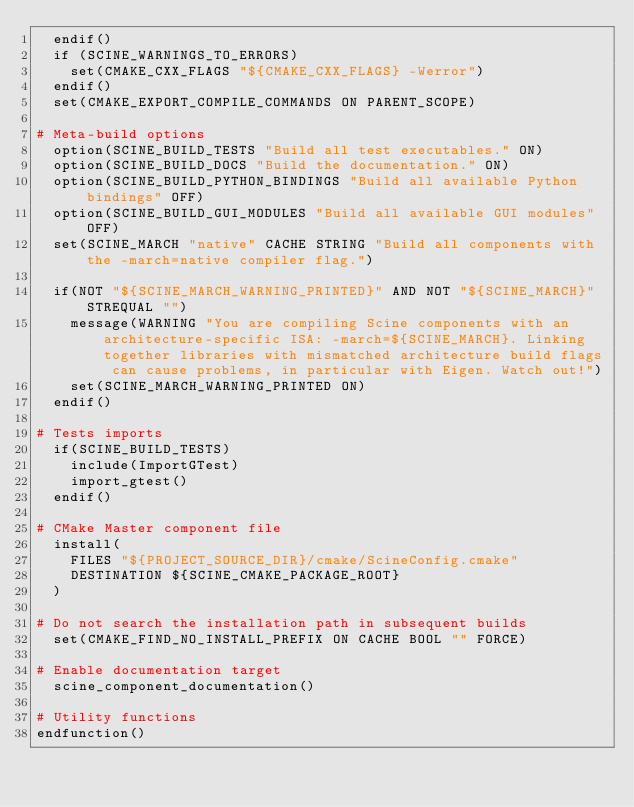Convert code to text. <code><loc_0><loc_0><loc_500><loc_500><_CMake_>  endif()
  if (SCINE_WARNINGS_TO_ERRORS)
    set(CMAKE_CXX_FLAGS "${CMAKE_CXX_FLAGS} -Werror")
  endif()
  set(CMAKE_EXPORT_COMPILE_COMMANDS ON PARENT_SCOPE)

# Meta-build options
  option(SCINE_BUILD_TESTS "Build all test executables." ON)
  option(SCINE_BUILD_DOCS "Build the documentation." ON)
  option(SCINE_BUILD_PYTHON_BINDINGS "Build all available Python bindings" OFF)
  option(SCINE_BUILD_GUI_MODULES "Build all available GUI modules" OFF)
  set(SCINE_MARCH "native" CACHE STRING "Build all components with the -march=native compiler flag.")

  if(NOT "${SCINE_MARCH_WARNING_PRINTED}" AND NOT "${SCINE_MARCH}" STREQUAL "")
    message(WARNING "You are compiling Scine components with an architecture-specific ISA: -march=${SCINE_MARCH}. Linking together libraries with mismatched architecture build flags can cause problems, in particular with Eigen. Watch out!")
    set(SCINE_MARCH_WARNING_PRINTED ON)
  endif()

# Tests imports
  if(SCINE_BUILD_TESTS)
    include(ImportGTest)
    import_gtest()
  endif()

# CMake Master component file
  install(
    FILES "${PROJECT_SOURCE_DIR}/cmake/ScineConfig.cmake"
    DESTINATION ${SCINE_CMAKE_PACKAGE_ROOT}
  )

# Do not search the installation path in subsequent builds
  set(CMAKE_FIND_NO_INSTALL_PREFIX ON CACHE BOOL "" FORCE)

# Enable documentation target
  scine_component_documentation()

# Utility functions
endfunction()
</code> 